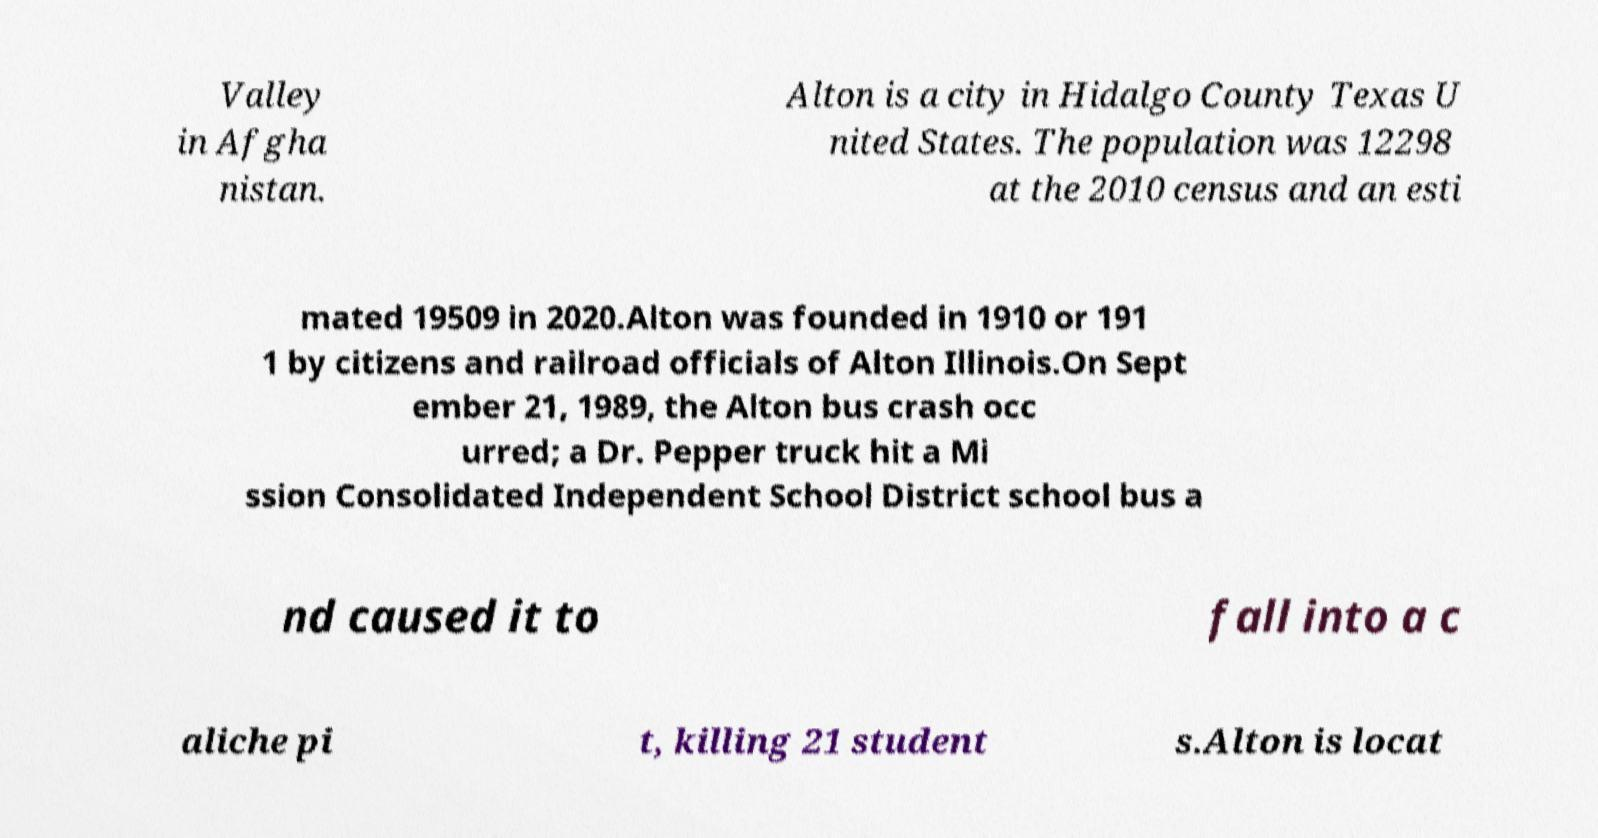Could you assist in decoding the text presented in this image and type it out clearly? Valley in Afgha nistan. Alton is a city in Hidalgo County Texas U nited States. The population was 12298 at the 2010 census and an esti mated 19509 in 2020.Alton was founded in 1910 or 191 1 by citizens and railroad officials of Alton Illinois.On Sept ember 21, 1989, the Alton bus crash occ urred; a Dr. Pepper truck hit a Mi ssion Consolidated Independent School District school bus a nd caused it to fall into a c aliche pi t, killing 21 student s.Alton is locat 